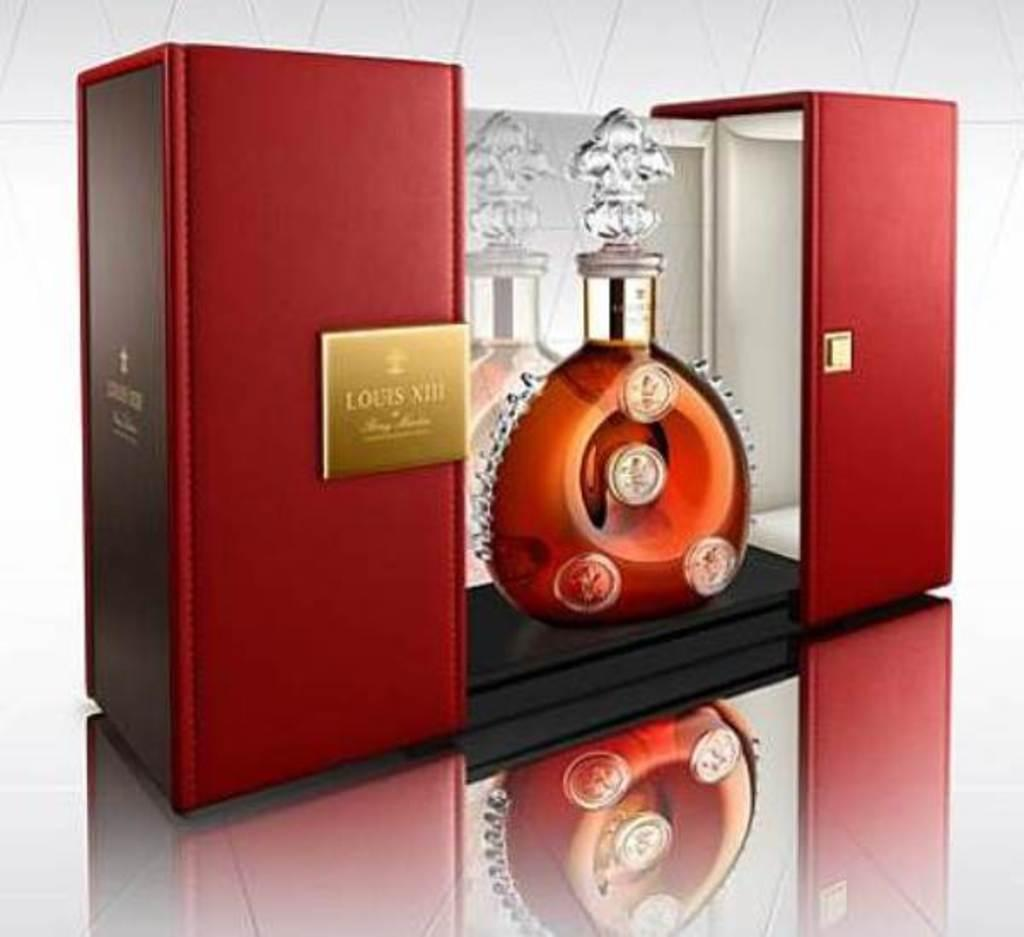Provide a one-sentence caption for the provided image. Glass decanter bottle of Louis VIII displayed within a beautiful red box. 